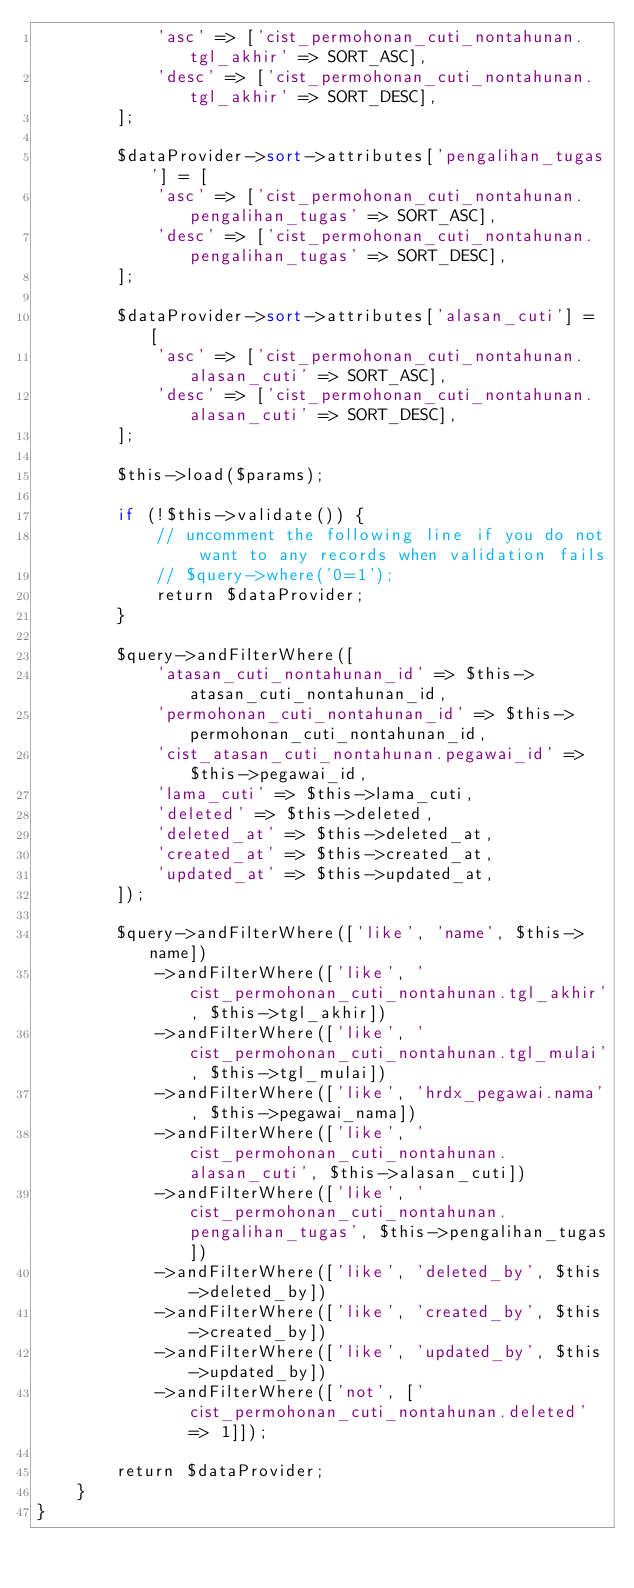Convert code to text. <code><loc_0><loc_0><loc_500><loc_500><_PHP_>            'asc' => ['cist_permohonan_cuti_nontahunan.tgl_akhir' => SORT_ASC],
            'desc' => ['cist_permohonan_cuti_nontahunan.tgl_akhir' => SORT_DESC],
        ];

        $dataProvider->sort->attributes['pengalihan_tugas'] = [
            'asc' => ['cist_permohonan_cuti_nontahunan.pengalihan_tugas' => SORT_ASC],
            'desc' => ['cist_permohonan_cuti_nontahunan.pengalihan_tugas' => SORT_DESC],
        ];

        $dataProvider->sort->attributes['alasan_cuti'] = [
            'asc' => ['cist_permohonan_cuti_nontahunan.alasan_cuti' => SORT_ASC],
            'desc' => ['cist_permohonan_cuti_nontahunan.alasan_cuti' => SORT_DESC],
        ];

        $this->load($params);

        if (!$this->validate()) {
            // uncomment the following line if you do not want to any records when validation fails
            // $query->where('0=1');
            return $dataProvider;
        }

        $query->andFilterWhere([
            'atasan_cuti_nontahunan_id' => $this->atasan_cuti_nontahunan_id,
            'permohonan_cuti_nontahunan_id' => $this->permohonan_cuti_nontahunan_id,
            'cist_atasan_cuti_nontahunan.pegawai_id' => $this->pegawai_id,
            'lama_cuti' => $this->lama_cuti,
            'deleted' => $this->deleted,
            'deleted_at' => $this->deleted_at,
            'created_at' => $this->created_at,
            'updated_at' => $this->updated_at,
        ]);

        $query->andFilterWhere(['like', 'name', $this->name])
            ->andFilterWhere(['like', 'cist_permohonan_cuti_nontahunan.tgl_akhir', $this->tgl_akhir])
            ->andFilterWhere(['like', 'cist_permohonan_cuti_nontahunan.tgl_mulai', $this->tgl_mulai])
            ->andFilterWhere(['like', 'hrdx_pegawai.nama', $this->pegawai_nama])
            ->andFilterWhere(['like', 'cist_permohonan_cuti_nontahunan.alasan_cuti', $this->alasan_cuti])
            ->andFilterWhere(['like', 'cist_permohonan_cuti_nontahunan.pengalihan_tugas', $this->pengalihan_tugas])
            ->andFilterWhere(['like', 'deleted_by', $this->deleted_by])
            ->andFilterWhere(['like', 'created_by', $this->created_by])
            ->andFilterWhere(['like', 'updated_by', $this->updated_by])
            ->andFilterWhere(['not', ['cist_permohonan_cuti_nontahunan.deleted' => 1]]);

        return $dataProvider;
    }
}
</code> 